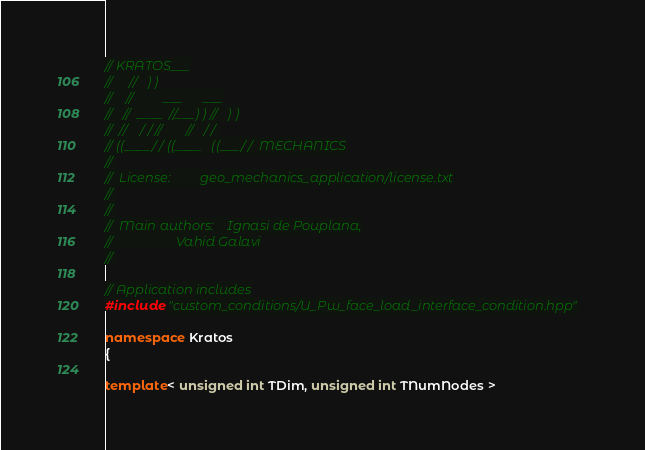<code> <loc_0><loc_0><loc_500><loc_500><_C++_>// KRATOS___
//     //   ) )
//    //         ___      ___
//   //  ____  //___) ) //   ) )
//  //    / / //       //   / /
// ((____/ / ((____   ((___/ /  MECHANICS
//
//  License:         geo_mechanics_application/license.txt
//
//
//  Main authors:    Ignasi de Pouplana,
//                   Vahid Galavi
//

// Application includes
#include "custom_conditions/U_Pw_face_load_interface_condition.hpp"

namespace Kratos
{

template< unsigned int TDim, unsigned int TNumNodes ></code> 